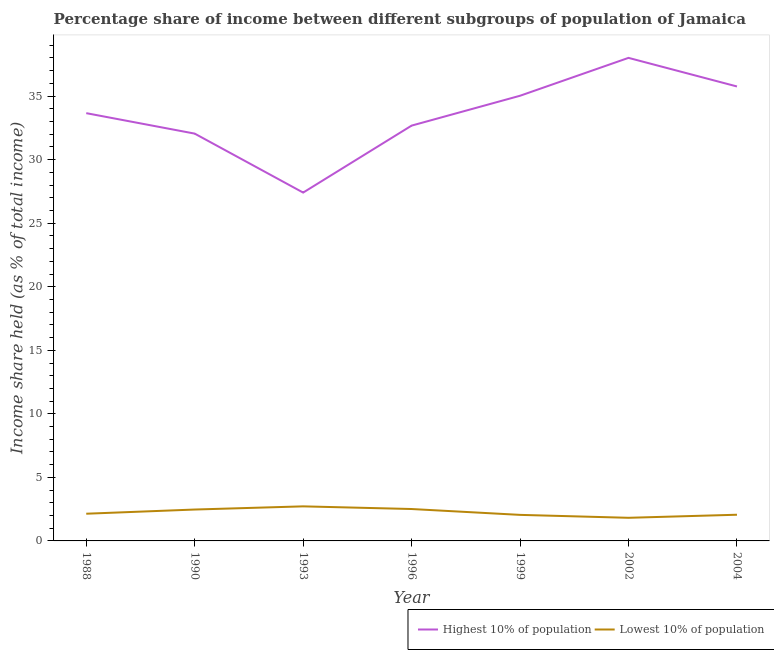How many different coloured lines are there?
Offer a terse response. 2. Does the line corresponding to income share held by lowest 10% of the population intersect with the line corresponding to income share held by highest 10% of the population?
Keep it short and to the point. No. What is the income share held by lowest 10% of the population in 1993?
Ensure brevity in your answer.  2.72. Across all years, what is the maximum income share held by highest 10% of the population?
Provide a succinct answer. 38.01. Across all years, what is the minimum income share held by lowest 10% of the population?
Your answer should be very brief. 1.82. In which year was the income share held by highest 10% of the population maximum?
Offer a very short reply. 2002. In which year was the income share held by lowest 10% of the population minimum?
Your answer should be very brief. 2002. What is the total income share held by lowest 10% of the population in the graph?
Give a very brief answer. 15.77. What is the difference between the income share held by highest 10% of the population in 1996 and that in 1999?
Provide a succinct answer. -2.35. What is the difference between the income share held by highest 10% of the population in 1990 and the income share held by lowest 10% of the population in 1999?
Offer a terse response. 30. What is the average income share held by lowest 10% of the population per year?
Your response must be concise. 2.25. In the year 1990, what is the difference between the income share held by highest 10% of the population and income share held by lowest 10% of the population?
Make the answer very short. 29.58. What is the ratio of the income share held by highest 10% of the population in 1990 to that in 2004?
Give a very brief answer. 0.9. Is the income share held by highest 10% of the population in 1988 less than that in 2002?
Provide a succinct answer. Yes. Is the difference between the income share held by highest 10% of the population in 1988 and 1996 greater than the difference between the income share held by lowest 10% of the population in 1988 and 1996?
Ensure brevity in your answer.  Yes. What is the difference between the highest and the second highest income share held by lowest 10% of the population?
Make the answer very short. 0.21. What is the difference between the highest and the lowest income share held by highest 10% of the population?
Give a very brief answer. 10.6. Does the income share held by highest 10% of the population monotonically increase over the years?
Ensure brevity in your answer.  No. Is the income share held by lowest 10% of the population strictly greater than the income share held by highest 10% of the population over the years?
Make the answer very short. No. Is the income share held by highest 10% of the population strictly less than the income share held by lowest 10% of the population over the years?
Your answer should be compact. No. What is the difference between two consecutive major ticks on the Y-axis?
Your response must be concise. 5. How many legend labels are there?
Your answer should be compact. 2. How are the legend labels stacked?
Offer a terse response. Horizontal. What is the title of the graph?
Make the answer very short. Percentage share of income between different subgroups of population of Jamaica. What is the label or title of the Y-axis?
Provide a succinct answer. Income share held (as % of total income). What is the Income share held (as % of total income) in Highest 10% of population in 1988?
Make the answer very short. 33.66. What is the Income share held (as % of total income) in Lowest 10% of population in 1988?
Make the answer very short. 2.14. What is the Income share held (as % of total income) in Highest 10% of population in 1990?
Keep it short and to the point. 32.05. What is the Income share held (as % of total income) in Lowest 10% of population in 1990?
Your answer should be compact. 2.47. What is the Income share held (as % of total income) in Highest 10% of population in 1993?
Keep it short and to the point. 27.41. What is the Income share held (as % of total income) in Lowest 10% of population in 1993?
Your answer should be compact. 2.72. What is the Income share held (as % of total income) of Highest 10% of population in 1996?
Your answer should be very brief. 32.68. What is the Income share held (as % of total income) in Lowest 10% of population in 1996?
Provide a short and direct response. 2.51. What is the Income share held (as % of total income) in Highest 10% of population in 1999?
Give a very brief answer. 35.03. What is the Income share held (as % of total income) in Lowest 10% of population in 1999?
Ensure brevity in your answer.  2.05. What is the Income share held (as % of total income) of Highest 10% of population in 2002?
Ensure brevity in your answer.  38.01. What is the Income share held (as % of total income) of Lowest 10% of population in 2002?
Your answer should be compact. 1.82. What is the Income share held (as % of total income) in Highest 10% of population in 2004?
Provide a short and direct response. 35.76. What is the Income share held (as % of total income) in Lowest 10% of population in 2004?
Keep it short and to the point. 2.06. Across all years, what is the maximum Income share held (as % of total income) in Highest 10% of population?
Your answer should be compact. 38.01. Across all years, what is the maximum Income share held (as % of total income) of Lowest 10% of population?
Your answer should be very brief. 2.72. Across all years, what is the minimum Income share held (as % of total income) of Highest 10% of population?
Offer a very short reply. 27.41. Across all years, what is the minimum Income share held (as % of total income) of Lowest 10% of population?
Your answer should be very brief. 1.82. What is the total Income share held (as % of total income) in Highest 10% of population in the graph?
Your answer should be compact. 234.6. What is the total Income share held (as % of total income) of Lowest 10% of population in the graph?
Keep it short and to the point. 15.77. What is the difference between the Income share held (as % of total income) in Highest 10% of population in 1988 and that in 1990?
Give a very brief answer. 1.61. What is the difference between the Income share held (as % of total income) in Lowest 10% of population in 1988 and that in 1990?
Provide a succinct answer. -0.33. What is the difference between the Income share held (as % of total income) of Highest 10% of population in 1988 and that in 1993?
Ensure brevity in your answer.  6.25. What is the difference between the Income share held (as % of total income) of Lowest 10% of population in 1988 and that in 1993?
Make the answer very short. -0.58. What is the difference between the Income share held (as % of total income) of Lowest 10% of population in 1988 and that in 1996?
Your response must be concise. -0.37. What is the difference between the Income share held (as % of total income) in Highest 10% of population in 1988 and that in 1999?
Keep it short and to the point. -1.37. What is the difference between the Income share held (as % of total income) of Lowest 10% of population in 1988 and that in 1999?
Provide a succinct answer. 0.09. What is the difference between the Income share held (as % of total income) of Highest 10% of population in 1988 and that in 2002?
Give a very brief answer. -4.35. What is the difference between the Income share held (as % of total income) in Lowest 10% of population in 1988 and that in 2002?
Your answer should be compact. 0.32. What is the difference between the Income share held (as % of total income) in Highest 10% of population in 1988 and that in 2004?
Ensure brevity in your answer.  -2.1. What is the difference between the Income share held (as % of total income) of Lowest 10% of population in 1988 and that in 2004?
Your answer should be very brief. 0.08. What is the difference between the Income share held (as % of total income) in Highest 10% of population in 1990 and that in 1993?
Your response must be concise. 4.64. What is the difference between the Income share held (as % of total income) of Highest 10% of population in 1990 and that in 1996?
Provide a succinct answer. -0.63. What is the difference between the Income share held (as % of total income) of Lowest 10% of population in 1990 and that in 1996?
Offer a very short reply. -0.04. What is the difference between the Income share held (as % of total income) of Highest 10% of population in 1990 and that in 1999?
Keep it short and to the point. -2.98. What is the difference between the Income share held (as % of total income) in Lowest 10% of population in 1990 and that in 1999?
Keep it short and to the point. 0.42. What is the difference between the Income share held (as % of total income) in Highest 10% of population in 1990 and that in 2002?
Offer a terse response. -5.96. What is the difference between the Income share held (as % of total income) of Lowest 10% of population in 1990 and that in 2002?
Ensure brevity in your answer.  0.65. What is the difference between the Income share held (as % of total income) of Highest 10% of population in 1990 and that in 2004?
Give a very brief answer. -3.71. What is the difference between the Income share held (as % of total income) in Lowest 10% of population in 1990 and that in 2004?
Make the answer very short. 0.41. What is the difference between the Income share held (as % of total income) of Highest 10% of population in 1993 and that in 1996?
Provide a succinct answer. -5.27. What is the difference between the Income share held (as % of total income) in Lowest 10% of population in 1993 and that in 1996?
Provide a short and direct response. 0.21. What is the difference between the Income share held (as % of total income) in Highest 10% of population in 1993 and that in 1999?
Give a very brief answer. -7.62. What is the difference between the Income share held (as % of total income) of Lowest 10% of population in 1993 and that in 1999?
Provide a short and direct response. 0.67. What is the difference between the Income share held (as % of total income) of Highest 10% of population in 1993 and that in 2004?
Offer a terse response. -8.35. What is the difference between the Income share held (as % of total income) in Lowest 10% of population in 1993 and that in 2004?
Your answer should be very brief. 0.66. What is the difference between the Income share held (as % of total income) in Highest 10% of population in 1996 and that in 1999?
Provide a succinct answer. -2.35. What is the difference between the Income share held (as % of total income) of Lowest 10% of population in 1996 and that in 1999?
Your answer should be compact. 0.46. What is the difference between the Income share held (as % of total income) of Highest 10% of population in 1996 and that in 2002?
Provide a short and direct response. -5.33. What is the difference between the Income share held (as % of total income) in Lowest 10% of population in 1996 and that in 2002?
Ensure brevity in your answer.  0.69. What is the difference between the Income share held (as % of total income) in Highest 10% of population in 1996 and that in 2004?
Offer a very short reply. -3.08. What is the difference between the Income share held (as % of total income) in Lowest 10% of population in 1996 and that in 2004?
Make the answer very short. 0.45. What is the difference between the Income share held (as % of total income) of Highest 10% of population in 1999 and that in 2002?
Your answer should be very brief. -2.98. What is the difference between the Income share held (as % of total income) in Lowest 10% of population in 1999 and that in 2002?
Keep it short and to the point. 0.23. What is the difference between the Income share held (as % of total income) of Highest 10% of population in 1999 and that in 2004?
Offer a very short reply. -0.73. What is the difference between the Income share held (as % of total income) of Lowest 10% of population in 1999 and that in 2004?
Make the answer very short. -0.01. What is the difference between the Income share held (as % of total income) in Highest 10% of population in 2002 and that in 2004?
Your response must be concise. 2.25. What is the difference between the Income share held (as % of total income) of Lowest 10% of population in 2002 and that in 2004?
Your answer should be very brief. -0.24. What is the difference between the Income share held (as % of total income) in Highest 10% of population in 1988 and the Income share held (as % of total income) in Lowest 10% of population in 1990?
Keep it short and to the point. 31.19. What is the difference between the Income share held (as % of total income) in Highest 10% of population in 1988 and the Income share held (as % of total income) in Lowest 10% of population in 1993?
Make the answer very short. 30.94. What is the difference between the Income share held (as % of total income) of Highest 10% of population in 1988 and the Income share held (as % of total income) of Lowest 10% of population in 1996?
Keep it short and to the point. 31.15. What is the difference between the Income share held (as % of total income) in Highest 10% of population in 1988 and the Income share held (as % of total income) in Lowest 10% of population in 1999?
Keep it short and to the point. 31.61. What is the difference between the Income share held (as % of total income) in Highest 10% of population in 1988 and the Income share held (as % of total income) in Lowest 10% of population in 2002?
Make the answer very short. 31.84. What is the difference between the Income share held (as % of total income) in Highest 10% of population in 1988 and the Income share held (as % of total income) in Lowest 10% of population in 2004?
Provide a succinct answer. 31.6. What is the difference between the Income share held (as % of total income) in Highest 10% of population in 1990 and the Income share held (as % of total income) in Lowest 10% of population in 1993?
Offer a very short reply. 29.33. What is the difference between the Income share held (as % of total income) of Highest 10% of population in 1990 and the Income share held (as % of total income) of Lowest 10% of population in 1996?
Ensure brevity in your answer.  29.54. What is the difference between the Income share held (as % of total income) in Highest 10% of population in 1990 and the Income share held (as % of total income) in Lowest 10% of population in 1999?
Offer a terse response. 30. What is the difference between the Income share held (as % of total income) of Highest 10% of population in 1990 and the Income share held (as % of total income) of Lowest 10% of population in 2002?
Ensure brevity in your answer.  30.23. What is the difference between the Income share held (as % of total income) of Highest 10% of population in 1990 and the Income share held (as % of total income) of Lowest 10% of population in 2004?
Your answer should be compact. 29.99. What is the difference between the Income share held (as % of total income) in Highest 10% of population in 1993 and the Income share held (as % of total income) in Lowest 10% of population in 1996?
Make the answer very short. 24.9. What is the difference between the Income share held (as % of total income) of Highest 10% of population in 1993 and the Income share held (as % of total income) of Lowest 10% of population in 1999?
Keep it short and to the point. 25.36. What is the difference between the Income share held (as % of total income) of Highest 10% of population in 1993 and the Income share held (as % of total income) of Lowest 10% of population in 2002?
Your response must be concise. 25.59. What is the difference between the Income share held (as % of total income) in Highest 10% of population in 1993 and the Income share held (as % of total income) in Lowest 10% of population in 2004?
Provide a short and direct response. 25.35. What is the difference between the Income share held (as % of total income) of Highest 10% of population in 1996 and the Income share held (as % of total income) of Lowest 10% of population in 1999?
Offer a terse response. 30.63. What is the difference between the Income share held (as % of total income) in Highest 10% of population in 1996 and the Income share held (as % of total income) in Lowest 10% of population in 2002?
Provide a short and direct response. 30.86. What is the difference between the Income share held (as % of total income) of Highest 10% of population in 1996 and the Income share held (as % of total income) of Lowest 10% of population in 2004?
Ensure brevity in your answer.  30.62. What is the difference between the Income share held (as % of total income) in Highest 10% of population in 1999 and the Income share held (as % of total income) in Lowest 10% of population in 2002?
Your answer should be compact. 33.21. What is the difference between the Income share held (as % of total income) in Highest 10% of population in 1999 and the Income share held (as % of total income) in Lowest 10% of population in 2004?
Keep it short and to the point. 32.97. What is the difference between the Income share held (as % of total income) of Highest 10% of population in 2002 and the Income share held (as % of total income) of Lowest 10% of population in 2004?
Give a very brief answer. 35.95. What is the average Income share held (as % of total income) in Highest 10% of population per year?
Ensure brevity in your answer.  33.51. What is the average Income share held (as % of total income) in Lowest 10% of population per year?
Provide a short and direct response. 2.25. In the year 1988, what is the difference between the Income share held (as % of total income) of Highest 10% of population and Income share held (as % of total income) of Lowest 10% of population?
Give a very brief answer. 31.52. In the year 1990, what is the difference between the Income share held (as % of total income) in Highest 10% of population and Income share held (as % of total income) in Lowest 10% of population?
Ensure brevity in your answer.  29.58. In the year 1993, what is the difference between the Income share held (as % of total income) in Highest 10% of population and Income share held (as % of total income) in Lowest 10% of population?
Ensure brevity in your answer.  24.69. In the year 1996, what is the difference between the Income share held (as % of total income) of Highest 10% of population and Income share held (as % of total income) of Lowest 10% of population?
Provide a succinct answer. 30.17. In the year 1999, what is the difference between the Income share held (as % of total income) of Highest 10% of population and Income share held (as % of total income) of Lowest 10% of population?
Provide a short and direct response. 32.98. In the year 2002, what is the difference between the Income share held (as % of total income) of Highest 10% of population and Income share held (as % of total income) of Lowest 10% of population?
Provide a succinct answer. 36.19. In the year 2004, what is the difference between the Income share held (as % of total income) in Highest 10% of population and Income share held (as % of total income) in Lowest 10% of population?
Keep it short and to the point. 33.7. What is the ratio of the Income share held (as % of total income) of Highest 10% of population in 1988 to that in 1990?
Your answer should be compact. 1.05. What is the ratio of the Income share held (as % of total income) of Lowest 10% of population in 1988 to that in 1990?
Give a very brief answer. 0.87. What is the ratio of the Income share held (as % of total income) of Highest 10% of population in 1988 to that in 1993?
Your answer should be compact. 1.23. What is the ratio of the Income share held (as % of total income) of Lowest 10% of population in 1988 to that in 1993?
Provide a succinct answer. 0.79. What is the ratio of the Income share held (as % of total income) of Lowest 10% of population in 1988 to that in 1996?
Make the answer very short. 0.85. What is the ratio of the Income share held (as % of total income) in Highest 10% of population in 1988 to that in 1999?
Make the answer very short. 0.96. What is the ratio of the Income share held (as % of total income) in Lowest 10% of population in 1988 to that in 1999?
Provide a succinct answer. 1.04. What is the ratio of the Income share held (as % of total income) of Highest 10% of population in 1988 to that in 2002?
Your answer should be compact. 0.89. What is the ratio of the Income share held (as % of total income) in Lowest 10% of population in 1988 to that in 2002?
Your response must be concise. 1.18. What is the ratio of the Income share held (as % of total income) in Highest 10% of population in 1988 to that in 2004?
Your answer should be very brief. 0.94. What is the ratio of the Income share held (as % of total income) in Lowest 10% of population in 1988 to that in 2004?
Your response must be concise. 1.04. What is the ratio of the Income share held (as % of total income) of Highest 10% of population in 1990 to that in 1993?
Your answer should be compact. 1.17. What is the ratio of the Income share held (as % of total income) in Lowest 10% of population in 1990 to that in 1993?
Give a very brief answer. 0.91. What is the ratio of the Income share held (as % of total income) of Highest 10% of population in 1990 to that in 1996?
Offer a very short reply. 0.98. What is the ratio of the Income share held (as % of total income) in Lowest 10% of population in 1990 to that in 1996?
Give a very brief answer. 0.98. What is the ratio of the Income share held (as % of total income) of Highest 10% of population in 1990 to that in 1999?
Your response must be concise. 0.91. What is the ratio of the Income share held (as % of total income) of Lowest 10% of population in 1990 to that in 1999?
Your answer should be very brief. 1.2. What is the ratio of the Income share held (as % of total income) of Highest 10% of population in 1990 to that in 2002?
Offer a very short reply. 0.84. What is the ratio of the Income share held (as % of total income) of Lowest 10% of population in 1990 to that in 2002?
Provide a short and direct response. 1.36. What is the ratio of the Income share held (as % of total income) in Highest 10% of population in 1990 to that in 2004?
Give a very brief answer. 0.9. What is the ratio of the Income share held (as % of total income) of Lowest 10% of population in 1990 to that in 2004?
Give a very brief answer. 1.2. What is the ratio of the Income share held (as % of total income) of Highest 10% of population in 1993 to that in 1996?
Make the answer very short. 0.84. What is the ratio of the Income share held (as % of total income) in Lowest 10% of population in 1993 to that in 1996?
Your answer should be very brief. 1.08. What is the ratio of the Income share held (as % of total income) of Highest 10% of population in 1993 to that in 1999?
Provide a succinct answer. 0.78. What is the ratio of the Income share held (as % of total income) in Lowest 10% of population in 1993 to that in 1999?
Offer a terse response. 1.33. What is the ratio of the Income share held (as % of total income) of Highest 10% of population in 1993 to that in 2002?
Your answer should be very brief. 0.72. What is the ratio of the Income share held (as % of total income) in Lowest 10% of population in 1993 to that in 2002?
Make the answer very short. 1.49. What is the ratio of the Income share held (as % of total income) in Highest 10% of population in 1993 to that in 2004?
Keep it short and to the point. 0.77. What is the ratio of the Income share held (as % of total income) in Lowest 10% of population in 1993 to that in 2004?
Offer a very short reply. 1.32. What is the ratio of the Income share held (as % of total income) in Highest 10% of population in 1996 to that in 1999?
Provide a succinct answer. 0.93. What is the ratio of the Income share held (as % of total income) of Lowest 10% of population in 1996 to that in 1999?
Your answer should be compact. 1.22. What is the ratio of the Income share held (as % of total income) of Highest 10% of population in 1996 to that in 2002?
Offer a very short reply. 0.86. What is the ratio of the Income share held (as % of total income) in Lowest 10% of population in 1996 to that in 2002?
Keep it short and to the point. 1.38. What is the ratio of the Income share held (as % of total income) of Highest 10% of population in 1996 to that in 2004?
Ensure brevity in your answer.  0.91. What is the ratio of the Income share held (as % of total income) in Lowest 10% of population in 1996 to that in 2004?
Offer a very short reply. 1.22. What is the ratio of the Income share held (as % of total income) in Highest 10% of population in 1999 to that in 2002?
Keep it short and to the point. 0.92. What is the ratio of the Income share held (as % of total income) in Lowest 10% of population in 1999 to that in 2002?
Make the answer very short. 1.13. What is the ratio of the Income share held (as % of total income) of Highest 10% of population in 1999 to that in 2004?
Offer a very short reply. 0.98. What is the ratio of the Income share held (as % of total income) of Lowest 10% of population in 1999 to that in 2004?
Your response must be concise. 1. What is the ratio of the Income share held (as % of total income) in Highest 10% of population in 2002 to that in 2004?
Offer a very short reply. 1.06. What is the ratio of the Income share held (as % of total income) of Lowest 10% of population in 2002 to that in 2004?
Provide a short and direct response. 0.88. What is the difference between the highest and the second highest Income share held (as % of total income) in Highest 10% of population?
Ensure brevity in your answer.  2.25. What is the difference between the highest and the second highest Income share held (as % of total income) of Lowest 10% of population?
Give a very brief answer. 0.21. What is the difference between the highest and the lowest Income share held (as % of total income) in Highest 10% of population?
Give a very brief answer. 10.6. What is the difference between the highest and the lowest Income share held (as % of total income) in Lowest 10% of population?
Provide a short and direct response. 0.9. 